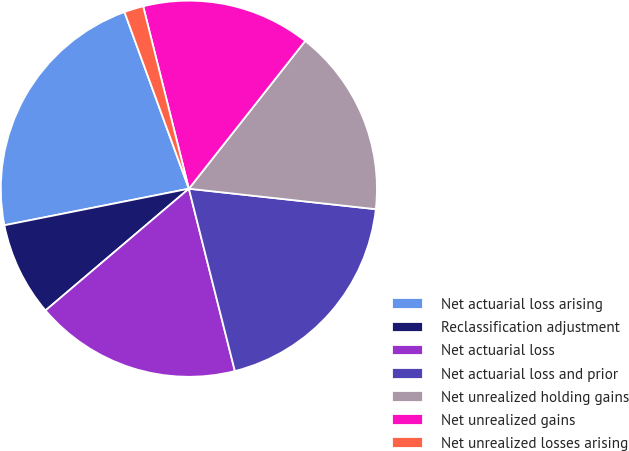<chart> <loc_0><loc_0><loc_500><loc_500><pie_chart><fcel>Net actuarial loss arising<fcel>Reclassification adjustment<fcel>Net actuarial loss<fcel>Net actuarial loss and prior<fcel>Net unrealized holding gains<fcel>Net unrealized gains<fcel>Net unrealized losses arising<nl><fcel>22.55%<fcel>8.09%<fcel>17.73%<fcel>19.33%<fcel>16.12%<fcel>14.52%<fcel>1.66%<nl></chart> 